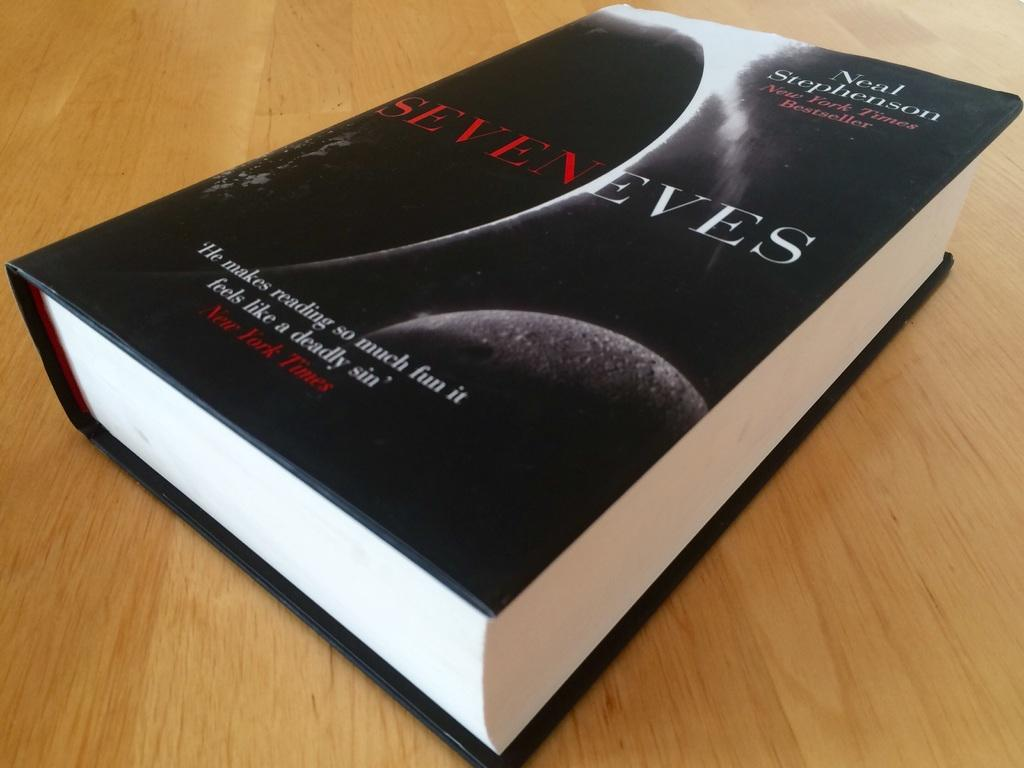<image>
Present a compact description of the photo's key features. The book Seven Eves was written by Neal Stephenson. 